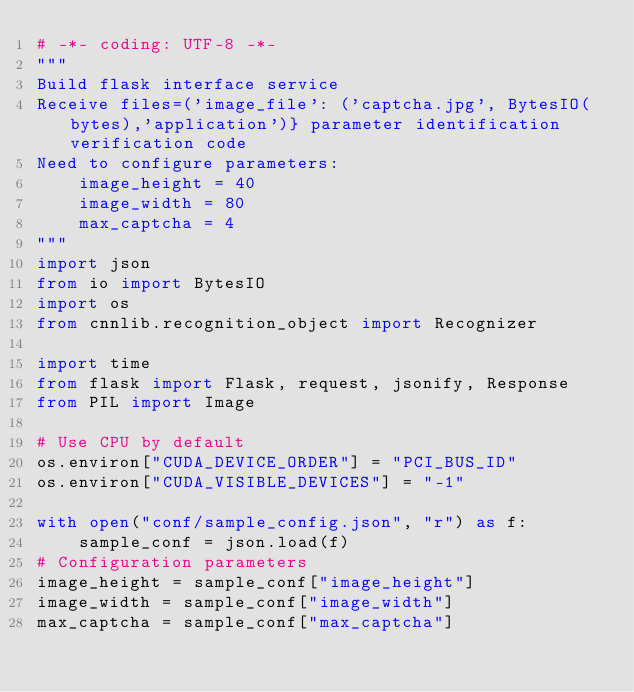<code> <loc_0><loc_0><loc_500><loc_500><_Python_># -*- coding: UTF-8 -*-
"""
Build flask interface service
Receive files=('image_file': ('captcha.jpg', BytesIO(bytes),'application')} parameter identification verification code
Need to configure parameters:
    image_height = 40
    image_width = 80
    max_captcha = 4
"""
import json
from io import BytesIO
import os
from cnnlib.recognition_object import Recognizer

import time
from flask import Flask, request, jsonify, Response
from PIL import Image

# Use CPU by default
os.environ["CUDA_DEVICE_ORDER"] = "PCI_BUS_ID"
os.environ["CUDA_VISIBLE_DEVICES"] = "-1"

with open("conf/sample_config.json", "r") as f:
    sample_conf = json.load(f)
# Configuration parameters
image_height = sample_conf["image_height"]
image_width = sample_conf["image_width"]
max_captcha = sample_conf["max_captcha"]</code> 